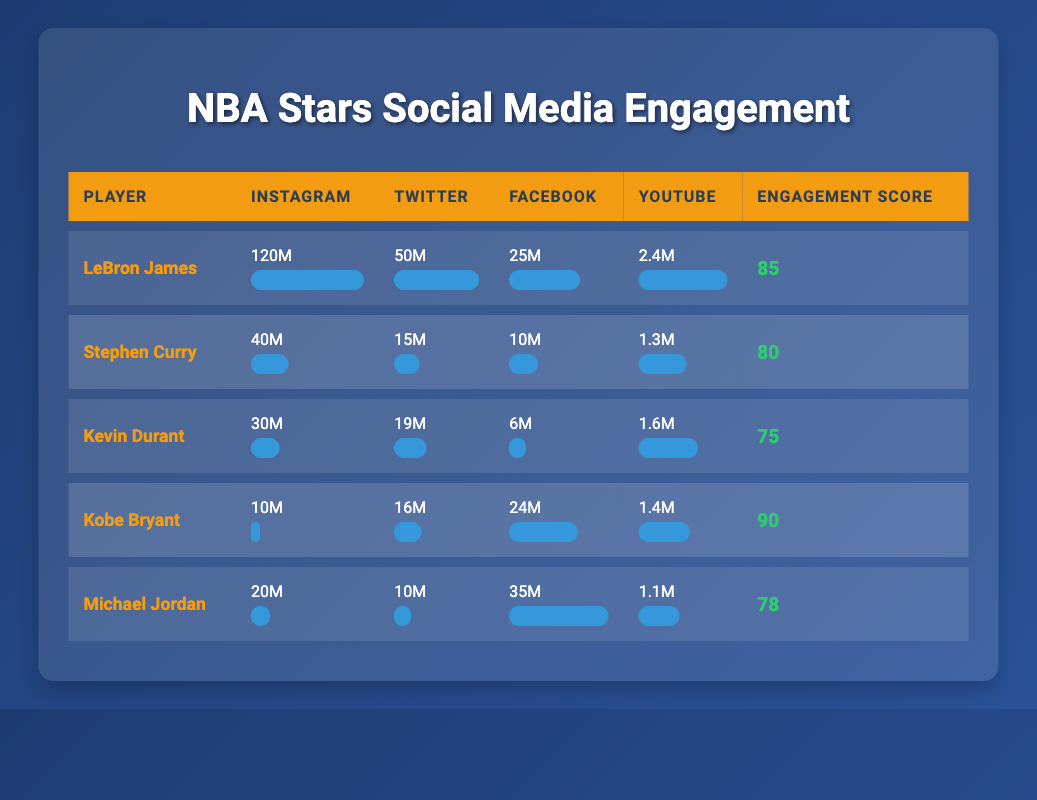What is the total number of Instagram followers for all players combined? To find the total, I will add the Instagram followers for each player: 120M + 40M + 30M + 10M + 20M = 220M.
Answer: 220M Which player has the highest engagement score? I will compare the engagement scores listed in the table: LeBron James (85), Stephen Curry (80), Kevin Durant (75), Kobe Bryant (90), and Michael Jordan (78). Kobe Bryant has the highest score of 90.
Answer: Kobe Bryant How many YouTube subscribers does Stephen Curry have compared to Kevin Durant? Stephen Curry has 1.3M YouTube subscribers, while Kevin Durant has 1.6M. To compare, I can see that 1.6M - 1.3M = 0.3M. Kevin Durant has 0.3M more subscribers than Stephen Curry.
Answer: 0.3M Is it true that Michael Jordan has more Facebook likes than both LeBron James and Kobe Bryant? Michael Jordan has 35M Facebook likes, LeBron James has 25M, and Kobe Bryant has 24M. Since 35M is greater than both 25M and 24M, the statement is true.
Answer: Yes What is the average number of Twitter followers for the players? To calculate the average, I will add the Twitter followers: 50M + 15M + 19M + 16M + 10M = 110M. There are 5 players, so I divide 110M by 5 to find the average: 110M / 5 = 22M.
Answer: 22M Which player has the fewest Instagram followers? Comparing the Instagram followers: LeBron James (120M), Stephen Curry (40M), Kevin Durant (30M), Kobe Bryant (10M), and Michael Jordan (20M), Kobe Bryant has the fewest at 10M.
Answer: Kobe Bryant How many more Facebook likes does Michael Jordan have than Stephen Curry? Michael Jordan has 35M Facebook likes and Stephen Curry has 10M. The difference is 35M - 10M = 25M. Michael Jordan has 25M more likes than Stephen Curry.
Answer: 25M Are the engagement scores of LeBron James and Kevin Durant above or below 80? LeBron James has an engagement score of 85, which is above 80, while Kevin Durant has a score of 75, which is below 80. Therefore, only LeBron James is above 80.
Answer: LeBron James What percentage of Facebook likes does Kobe Bryant have compared to Michael Jordan? Kobe Bryant has 24M likes and Michael Jordan has 35M likes. To find the percentage, I calculate (24M / 35M) * 100 = 68.57%. Kobe Bryant has approximately 68.57% of Michael Jordan's likes.
Answer: 68.57% 